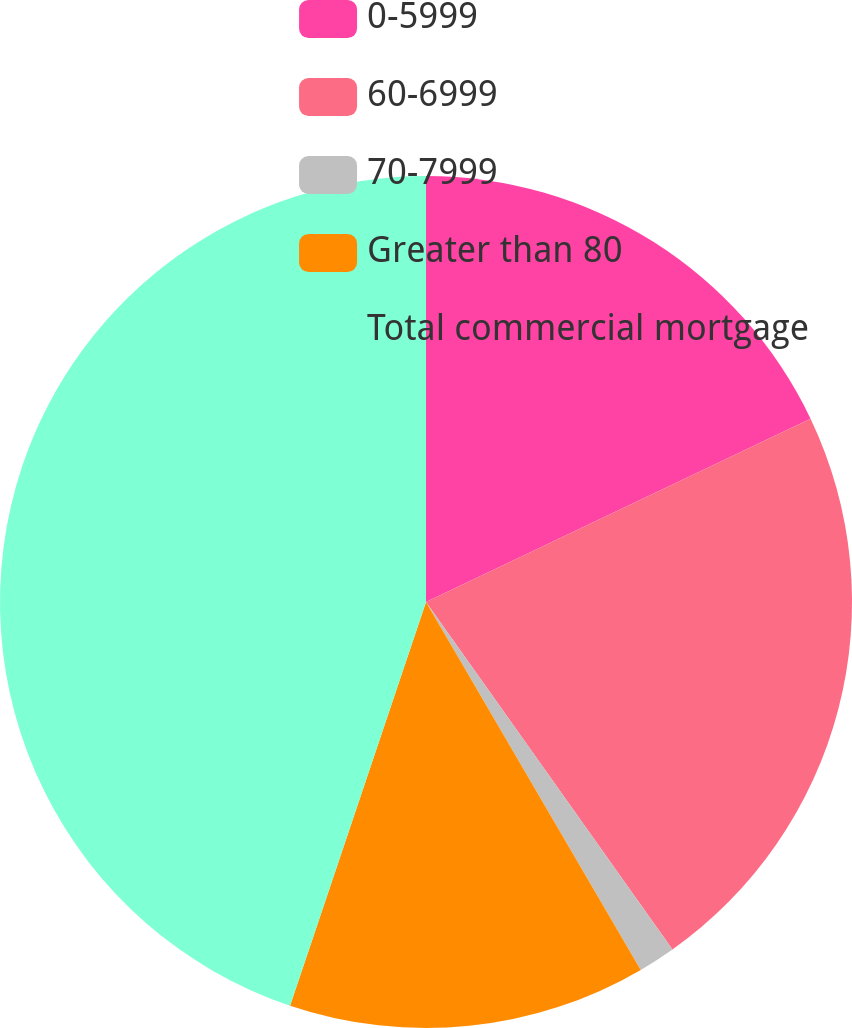Convert chart to OTSL. <chart><loc_0><loc_0><loc_500><loc_500><pie_chart><fcel>0-5999<fcel>60-6999<fcel>70-7999<fcel>Greater than 80<fcel>Total commercial mortgage<nl><fcel>17.92%<fcel>22.26%<fcel>1.41%<fcel>13.58%<fcel>44.83%<nl></chart> 